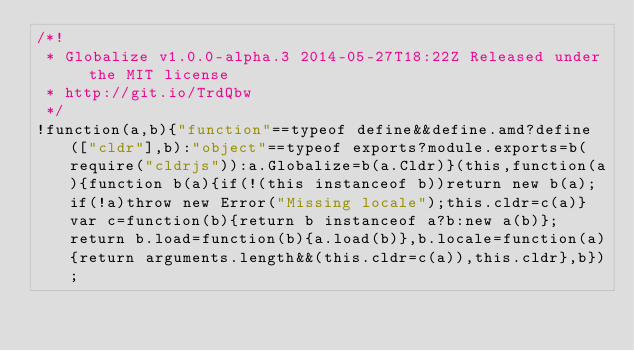Convert code to text. <code><loc_0><loc_0><loc_500><loc_500><_JavaScript_>/*!
 * Globalize v1.0.0-alpha.3 2014-05-27T18:22Z Released under the MIT license
 * http://git.io/TrdQbw
 */
!function(a,b){"function"==typeof define&&define.amd?define(["cldr"],b):"object"==typeof exports?module.exports=b(require("cldrjs")):a.Globalize=b(a.Cldr)}(this,function(a){function b(a){if(!(this instanceof b))return new b(a);if(!a)throw new Error("Missing locale");this.cldr=c(a)}var c=function(b){return b instanceof a?b:new a(b)};return b.load=function(b){a.load(b)},b.locale=function(a){return arguments.length&&(this.cldr=c(a)),this.cldr},b});</code> 